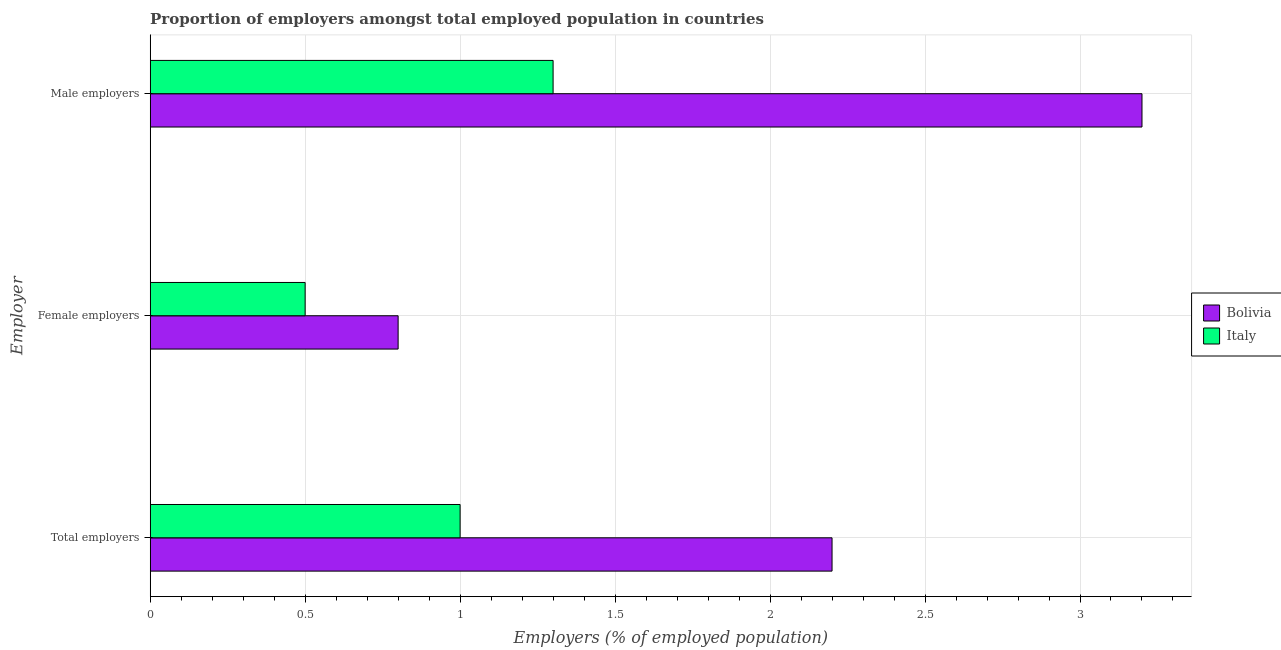How many groups of bars are there?
Keep it short and to the point. 3. Are the number of bars per tick equal to the number of legend labels?
Your answer should be compact. Yes. Are the number of bars on each tick of the Y-axis equal?
Your answer should be very brief. Yes. How many bars are there on the 3rd tick from the top?
Provide a succinct answer. 2. What is the label of the 2nd group of bars from the top?
Provide a short and direct response. Female employers. What is the percentage of male employers in Bolivia?
Provide a succinct answer. 3.2. Across all countries, what is the maximum percentage of female employers?
Provide a succinct answer. 0.8. Across all countries, what is the minimum percentage of male employers?
Keep it short and to the point. 1.3. In which country was the percentage of female employers maximum?
Your answer should be compact. Bolivia. In which country was the percentage of total employers minimum?
Give a very brief answer. Italy. What is the total percentage of total employers in the graph?
Your answer should be compact. 3.2. What is the difference between the percentage of female employers in Bolivia and that in Italy?
Your response must be concise. 0.3. What is the difference between the percentage of female employers in Bolivia and the percentage of male employers in Italy?
Ensure brevity in your answer.  -0.5. What is the average percentage of male employers per country?
Offer a very short reply. 2.25. What is the difference between the percentage of male employers and percentage of total employers in Italy?
Your response must be concise. 0.3. What is the ratio of the percentage of total employers in Italy to that in Bolivia?
Keep it short and to the point. 0.45. Is the percentage of total employers in Italy less than that in Bolivia?
Make the answer very short. Yes. Is the difference between the percentage of male employers in Bolivia and Italy greater than the difference between the percentage of total employers in Bolivia and Italy?
Keep it short and to the point. Yes. What is the difference between the highest and the second highest percentage of male employers?
Make the answer very short. 1.9. What is the difference between the highest and the lowest percentage of male employers?
Provide a succinct answer. 1.9. Is the sum of the percentage of female employers in Italy and Bolivia greater than the maximum percentage of total employers across all countries?
Offer a terse response. No. How many bars are there?
Offer a terse response. 6. How many countries are there in the graph?
Keep it short and to the point. 2. Are the values on the major ticks of X-axis written in scientific E-notation?
Make the answer very short. No. Does the graph contain any zero values?
Give a very brief answer. No. Does the graph contain grids?
Your answer should be very brief. Yes. Where does the legend appear in the graph?
Your answer should be very brief. Center right. How many legend labels are there?
Your response must be concise. 2. What is the title of the graph?
Give a very brief answer. Proportion of employers amongst total employed population in countries. What is the label or title of the X-axis?
Your answer should be very brief. Employers (% of employed population). What is the label or title of the Y-axis?
Offer a terse response. Employer. What is the Employers (% of employed population) of Bolivia in Total employers?
Your answer should be compact. 2.2. What is the Employers (% of employed population) of Italy in Total employers?
Offer a very short reply. 1. What is the Employers (% of employed population) in Bolivia in Female employers?
Offer a very short reply. 0.8. What is the Employers (% of employed population) of Italy in Female employers?
Your answer should be very brief. 0.5. What is the Employers (% of employed population) in Bolivia in Male employers?
Offer a terse response. 3.2. What is the Employers (% of employed population) of Italy in Male employers?
Your answer should be very brief. 1.3. Across all Employer, what is the maximum Employers (% of employed population) of Bolivia?
Your response must be concise. 3.2. Across all Employer, what is the maximum Employers (% of employed population) in Italy?
Make the answer very short. 1.3. Across all Employer, what is the minimum Employers (% of employed population) of Bolivia?
Your answer should be compact. 0.8. What is the total Employers (% of employed population) in Bolivia in the graph?
Give a very brief answer. 6.2. What is the total Employers (% of employed population) in Italy in the graph?
Keep it short and to the point. 2.8. What is the difference between the Employers (% of employed population) in Bolivia in Total employers and that in Female employers?
Your response must be concise. 1.4. What is the difference between the Employers (% of employed population) of Bolivia in Female employers and that in Male employers?
Your answer should be very brief. -2.4. What is the difference between the Employers (% of employed population) in Italy in Female employers and that in Male employers?
Make the answer very short. -0.8. What is the difference between the Employers (% of employed population) in Bolivia in Total employers and the Employers (% of employed population) in Italy in Female employers?
Offer a terse response. 1.7. What is the difference between the Employers (% of employed population) in Bolivia in Total employers and the Employers (% of employed population) in Italy in Male employers?
Offer a very short reply. 0.9. What is the difference between the Employers (% of employed population) of Bolivia in Female employers and the Employers (% of employed population) of Italy in Male employers?
Give a very brief answer. -0.5. What is the average Employers (% of employed population) in Bolivia per Employer?
Keep it short and to the point. 2.07. What is the average Employers (% of employed population) of Italy per Employer?
Make the answer very short. 0.93. What is the difference between the Employers (% of employed population) of Bolivia and Employers (% of employed population) of Italy in Male employers?
Give a very brief answer. 1.9. What is the ratio of the Employers (% of employed population) in Bolivia in Total employers to that in Female employers?
Offer a terse response. 2.75. What is the ratio of the Employers (% of employed population) in Bolivia in Total employers to that in Male employers?
Provide a short and direct response. 0.69. What is the ratio of the Employers (% of employed population) in Italy in Total employers to that in Male employers?
Provide a short and direct response. 0.77. What is the ratio of the Employers (% of employed population) of Bolivia in Female employers to that in Male employers?
Your answer should be compact. 0.25. What is the ratio of the Employers (% of employed population) in Italy in Female employers to that in Male employers?
Provide a short and direct response. 0.38. What is the difference between the highest and the second highest Employers (% of employed population) in Bolivia?
Offer a terse response. 1. What is the difference between the highest and the lowest Employers (% of employed population) of Bolivia?
Offer a very short reply. 2.4. What is the difference between the highest and the lowest Employers (% of employed population) of Italy?
Ensure brevity in your answer.  0.8. 